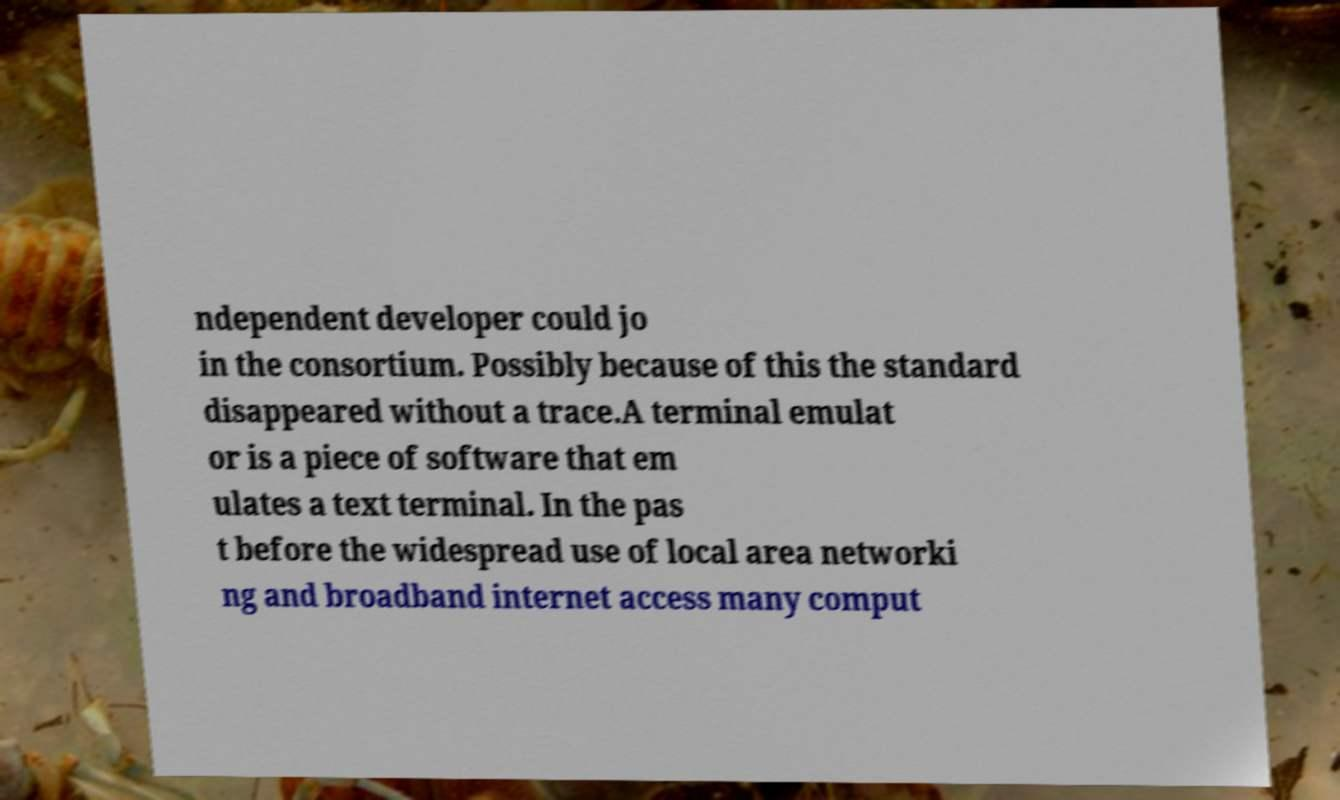Can you read and provide the text displayed in the image?This photo seems to have some interesting text. Can you extract and type it out for me? ndependent developer could jo in the consortium. Possibly because of this the standard disappeared without a trace.A terminal emulat or is a piece of software that em ulates a text terminal. In the pas t before the widespread use of local area networki ng and broadband internet access many comput 